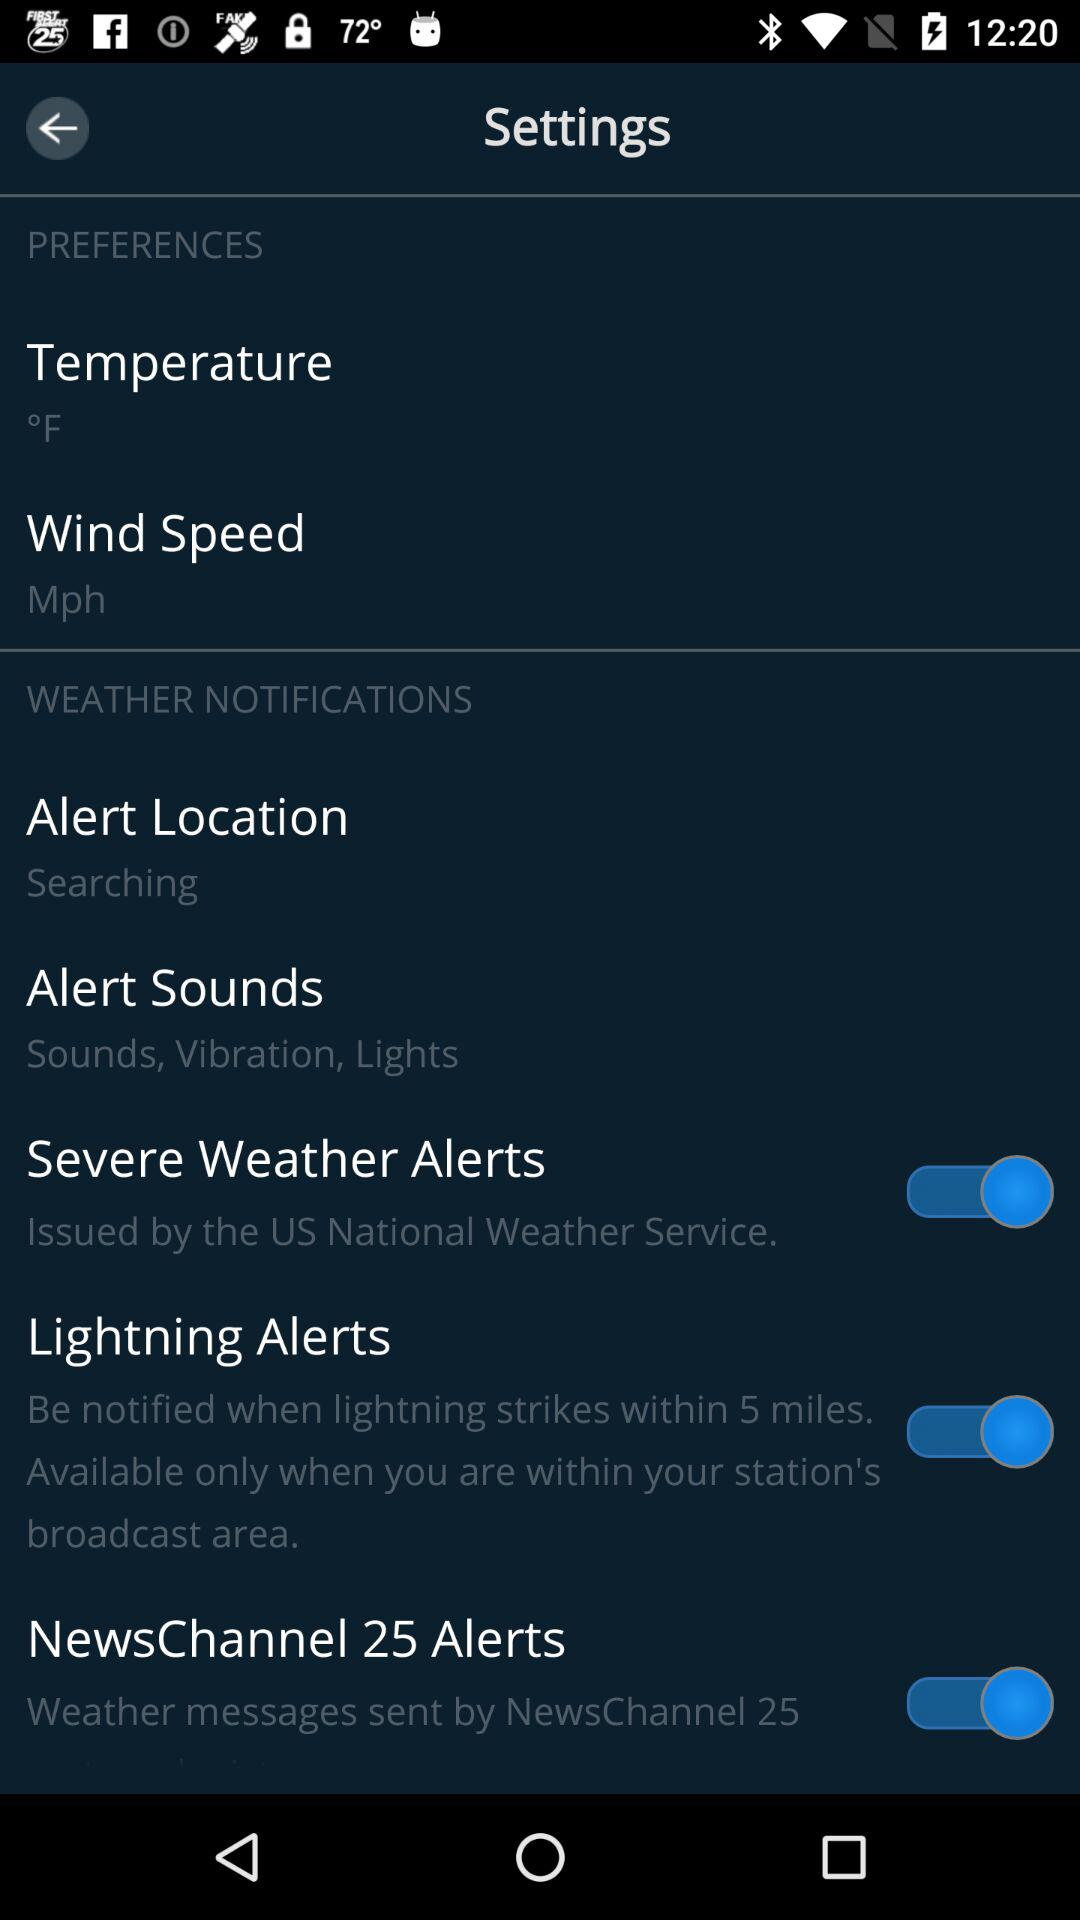What is the unit of temperature? The unit of temperature is °F. 